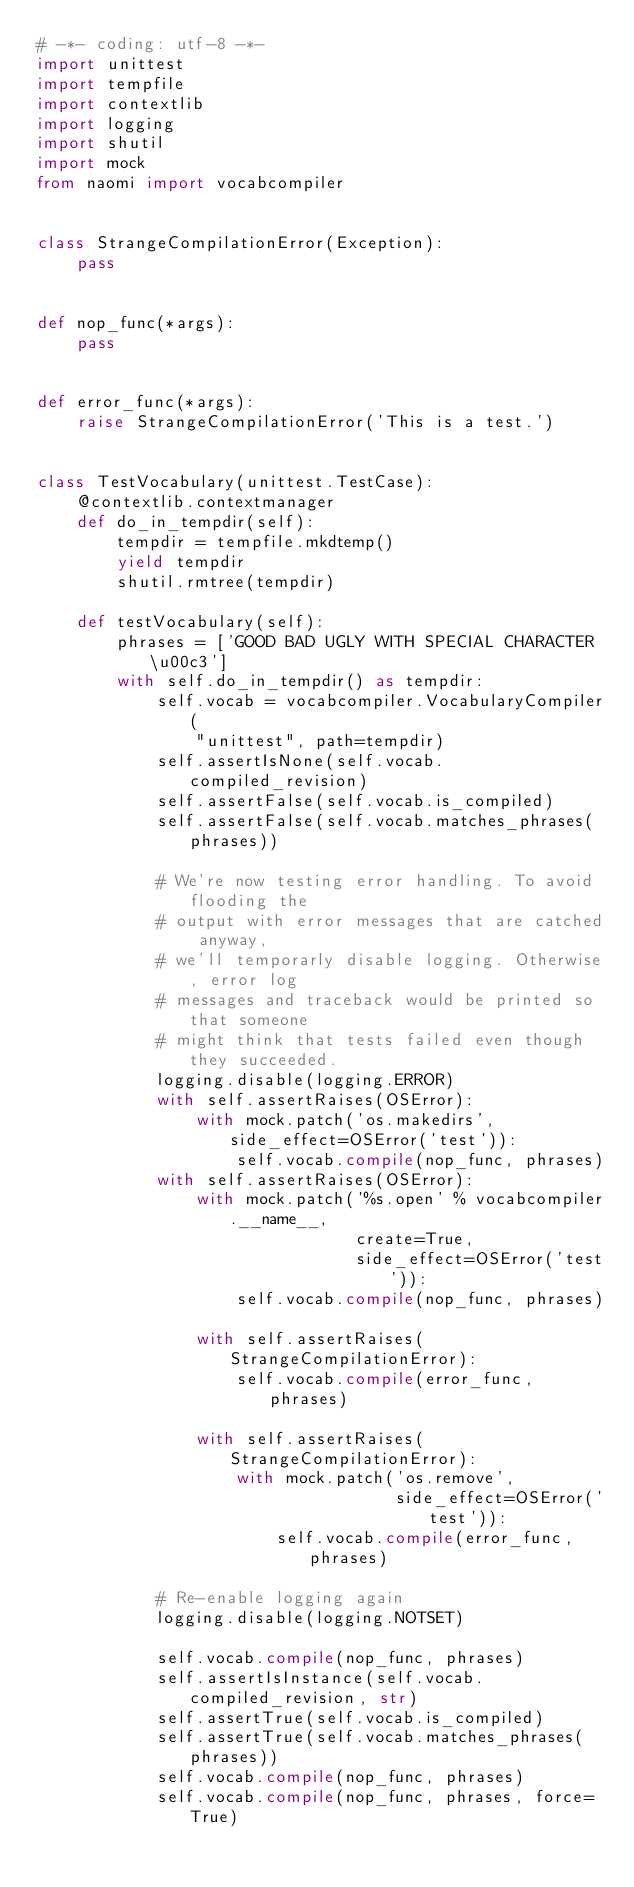Convert code to text. <code><loc_0><loc_0><loc_500><loc_500><_Python_># -*- coding: utf-8 -*-
import unittest
import tempfile
import contextlib
import logging
import shutil
import mock
from naomi import vocabcompiler


class StrangeCompilationError(Exception):
    pass


def nop_func(*args):
    pass


def error_func(*args):
    raise StrangeCompilationError('This is a test.')


class TestVocabulary(unittest.TestCase):
    @contextlib.contextmanager
    def do_in_tempdir(self):
        tempdir = tempfile.mkdtemp()
        yield tempdir
        shutil.rmtree(tempdir)

    def testVocabulary(self):
        phrases = ['GOOD BAD UGLY WITH SPECIAL CHARACTER \u00c3']
        with self.do_in_tempdir() as tempdir:
            self.vocab = vocabcompiler.VocabularyCompiler(
                "unittest", path=tempdir)
            self.assertIsNone(self.vocab.compiled_revision)
            self.assertFalse(self.vocab.is_compiled)
            self.assertFalse(self.vocab.matches_phrases(phrases))

            # We're now testing error handling. To avoid flooding the
            # output with error messages that are catched anyway,
            # we'll temporarly disable logging. Otherwise, error log
            # messages and traceback would be printed so that someone
            # might think that tests failed even though they succeeded.
            logging.disable(logging.ERROR)
            with self.assertRaises(OSError):
                with mock.patch('os.makedirs', side_effect=OSError('test')):
                    self.vocab.compile(nop_func, phrases)
            with self.assertRaises(OSError):
                with mock.patch('%s.open' % vocabcompiler.__name__,
                                create=True,
                                side_effect=OSError('test')):
                    self.vocab.compile(nop_func, phrases)

                with self.assertRaises(StrangeCompilationError):
                    self.vocab.compile(error_func, phrases)

                with self.assertRaises(StrangeCompilationError):
                    with mock.patch('os.remove',
                                    side_effect=OSError('test')):
                        self.vocab.compile(error_func, phrases)

            # Re-enable logging again
            logging.disable(logging.NOTSET)

            self.vocab.compile(nop_func, phrases)
            self.assertIsInstance(self.vocab.compiled_revision, str)
            self.assertTrue(self.vocab.is_compiled)
            self.assertTrue(self.vocab.matches_phrases(phrases))
            self.vocab.compile(nop_func, phrases)
            self.vocab.compile(nop_func, phrases, force=True)
</code> 